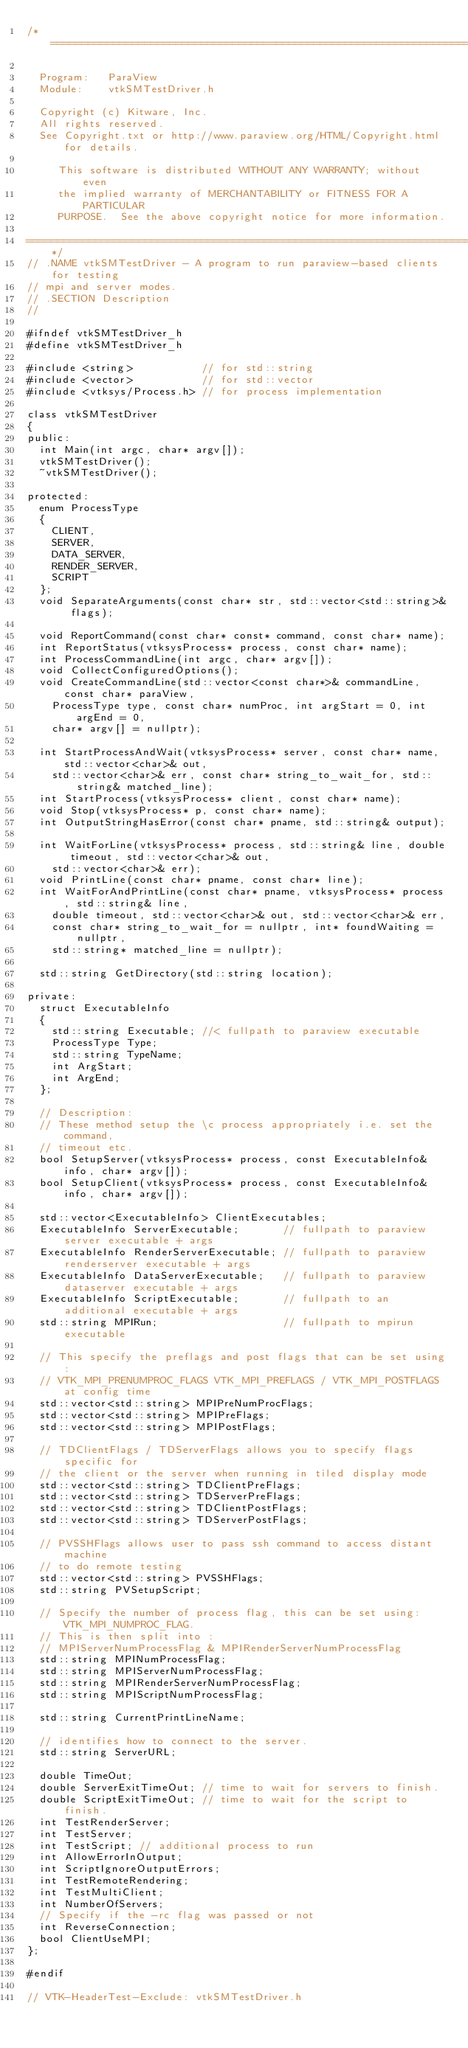Convert code to text. <code><loc_0><loc_0><loc_500><loc_500><_C_>/*=========================================================================

  Program:   ParaView
  Module:    vtkSMTestDriver.h

  Copyright (c) Kitware, Inc.
  All rights reserved.
  See Copyright.txt or http://www.paraview.org/HTML/Copyright.html for details.

     This software is distributed WITHOUT ANY WARRANTY; without even
     the implied warranty of MERCHANTABILITY or FITNESS FOR A PARTICULAR
     PURPOSE.  See the above copyright notice for more information.

=========================================================================*/
// .NAME vtkSMTestDriver - A program to run paraview-based clients for testing
// mpi and server modes.
// .SECTION Description
//

#ifndef vtkSMTestDriver_h
#define vtkSMTestDriver_h

#include <string>           // for std::string
#include <vector>           // for std::vector
#include <vtksys/Process.h> // for process implementation

class vtkSMTestDriver
{
public:
  int Main(int argc, char* argv[]);
  vtkSMTestDriver();
  ~vtkSMTestDriver();

protected:
  enum ProcessType
  {
    CLIENT,
    SERVER,
    DATA_SERVER,
    RENDER_SERVER,
    SCRIPT
  };
  void SeparateArguments(const char* str, std::vector<std::string>& flags);

  void ReportCommand(const char* const* command, const char* name);
  int ReportStatus(vtksysProcess* process, const char* name);
  int ProcessCommandLine(int argc, char* argv[]);
  void CollectConfiguredOptions();
  void CreateCommandLine(std::vector<const char*>& commandLine, const char* paraView,
    ProcessType type, const char* numProc, int argStart = 0, int argEnd = 0,
    char* argv[] = nullptr);

  int StartProcessAndWait(vtksysProcess* server, const char* name, std::vector<char>& out,
    std::vector<char>& err, const char* string_to_wait_for, std::string& matched_line);
  int StartProcess(vtksysProcess* client, const char* name);
  void Stop(vtksysProcess* p, const char* name);
  int OutputStringHasError(const char* pname, std::string& output);

  int WaitForLine(vtksysProcess* process, std::string& line, double timeout, std::vector<char>& out,
    std::vector<char>& err);
  void PrintLine(const char* pname, const char* line);
  int WaitForAndPrintLine(const char* pname, vtksysProcess* process, std::string& line,
    double timeout, std::vector<char>& out, std::vector<char>& err,
    const char* string_to_wait_for = nullptr, int* foundWaiting = nullptr,
    std::string* matched_line = nullptr);

  std::string GetDirectory(std::string location);

private:
  struct ExecutableInfo
  {
    std::string Executable; //< fullpath to paraview executable
    ProcessType Type;
    std::string TypeName;
    int ArgStart;
    int ArgEnd;
  };

  // Description:
  // These method setup the \c process appropriately i.e. set the command,
  // timeout etc.
  bool SetupServer(vtksysProcess* process, const ExecutableInfo& info, char* argv[]);
  bool SetupClient(vtksysProcess* process, const ExecutableInfo& info, char* argv[]);

  std::vector<ExecutableInfo> ClientExecutables;
  ExecutableInfo ServerExecutable;       // fullpath to paraview server executable + args
  ExecutableInfo RenderServerExecutable; // fullpath to paraview renderserver executable + args
  ExecutableInfo DataServerExecutable;   // fullpath to paraview dataserver executable + args
  ExecutableInfo ScriptExecutable;       // fullpath to an additional executable + args
  std::string MPIRun;                    // fullpath to mpirun executable

  // This specify the preflags and post flags that can be set using:
  // VTK_MPI_PRENUMPROC_FLAGS VTK_MPI_PREFLAGS / VTK_MPI_POSTFLAGS at config time
  std::vector<std::string> MPIPreNumProcFlags;
  std::vector<std::string> MPIPreFlags;
  std::vector<std::string> MPIPostFlags;

  // TDClientFlags / TDServerFlags allows you to specify flags specific for
  // the client or the server when running in tiled display mode
  std::vector<std::string> TDClientPreFlags;
  std::vector<std::string> TDServerPreFlags;
  std::vector<std::string> TDClientPostFlags;
  std::vector<std::string> TDServerPostFlags;

  // PVSSHFlags allows user to pass ssh command to access distant machine
  // to do remote testing
  std::vector<std::string> PVSSHFlags;
  std::string PVSetupScript;

  // Specify the number of process flag, this can be set using: VTK_MPI_NUMPROC_FLAG.
  // This is then split into :
  // MPIServerNumProcessFlag & MPIRenderServerNumProcessFlag
  std::string MPINumProcessFlag;
  std::string MPIServerNumProcessFlag;
  std::string MPIRenderServerNumProcessFlag;
  std::string MPIScriptNumProcessFlag;

  std::string CurrentPrintLineName;

  // identifies how to connect to the server.
  std::string ServerURL;

  double TimeOut;
  double ServerExitTimeOut; // time to wait for servers to finish.
  double ScriptExitTimeOut; // time to wait for the script to finish.
  int TestRenderServer;
  int TestServer;
  int TestScript; // additional process to run
  int AllowErrorInOutput;
  int ScriptIgnoreOutputErrors;
  int TestRemoteRendering;
  int TestMultiClient;
  int NumberOfServers;
  // Specify if the -rc flag was passed or not
  int ReverseConnection;
  bool ClientUseMPI;
};

#endif

// VTK-HeaderTest-Exclude: vtkSMTestDriver.h
</code> 